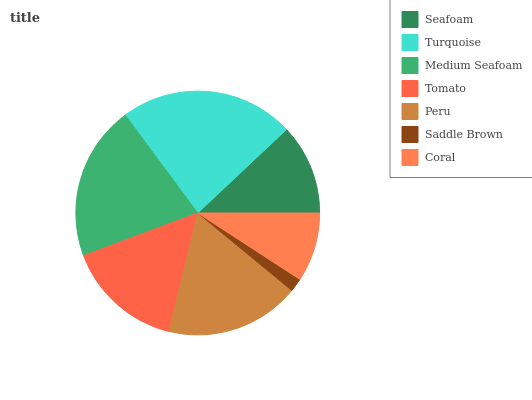Is Saddle Brown the minimum?
Answer yes or no. Yes. Is Turquoise the maximum?
Answer yes or no. Yes. Is Medium Seafoam the minimum?
Answer yes or no. No. Is Medium Seafoam the maximum?
Answer yes or no. No. Is Turquoise greater than Medium Seafoam?
Answer yes or no. Yes. Is Medium Seafoam less than Turquoise?
Answer yes or no. Yes. Is Medium Seafoam greater than Turquoise?
Answer yes or no. No. Is Turquoise less than Medium Seafoam?
Answer yes or no. No. Is Tomato the high median?
Answer yes or no. Yes. Is Tomato the low median?
Answer yes or no. Yes. Is Peru the high median?
Answer yes or no. No. Is Peru the low median?
Answer yes or no. No. 